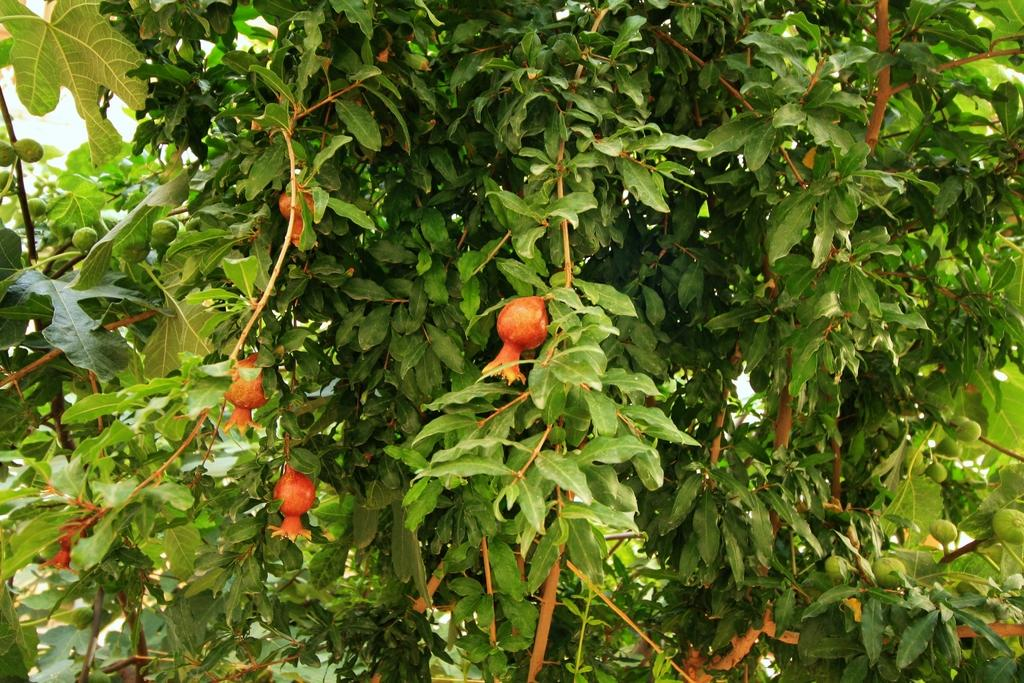What type of vegetation can be seen on the trees in the image? There are fruits on the trees in the image. Can you describe the fruits on the trees? Unfortunately, the specific type of fruits cannot be determined from the image alone. What might be a possible use for the fruits on the trees? The fruits on the trees could be harvested for consumption or other purposes. What type of stew is being prepared in the image? There is no stew present in the image; it features fruits on trees. Can you describe the quiver that is hanging on the tree in the image? There is no quiver present in the image; it only shows fruits on trees. 